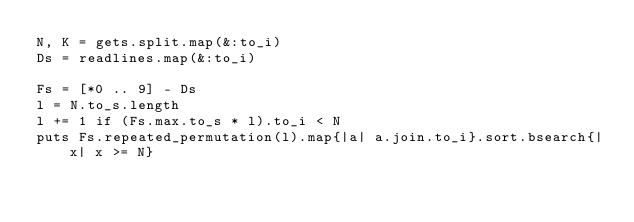<code> <loc_0><loc_0><loc_500><loc_500><_Ruby_>N, K = gets.split.map(&:to_i)
Ds = readlines.map(&:to_i)

Fs = [*0 .. 9] - Ds
l = N.to_s.length
l += 1 if (Fs.max.to_s * l).to_i < N
puts Fs.repeated_permutation(l).map{|a| a.join.to_i}.sort.bsearch{|x| x >= N}</code> 